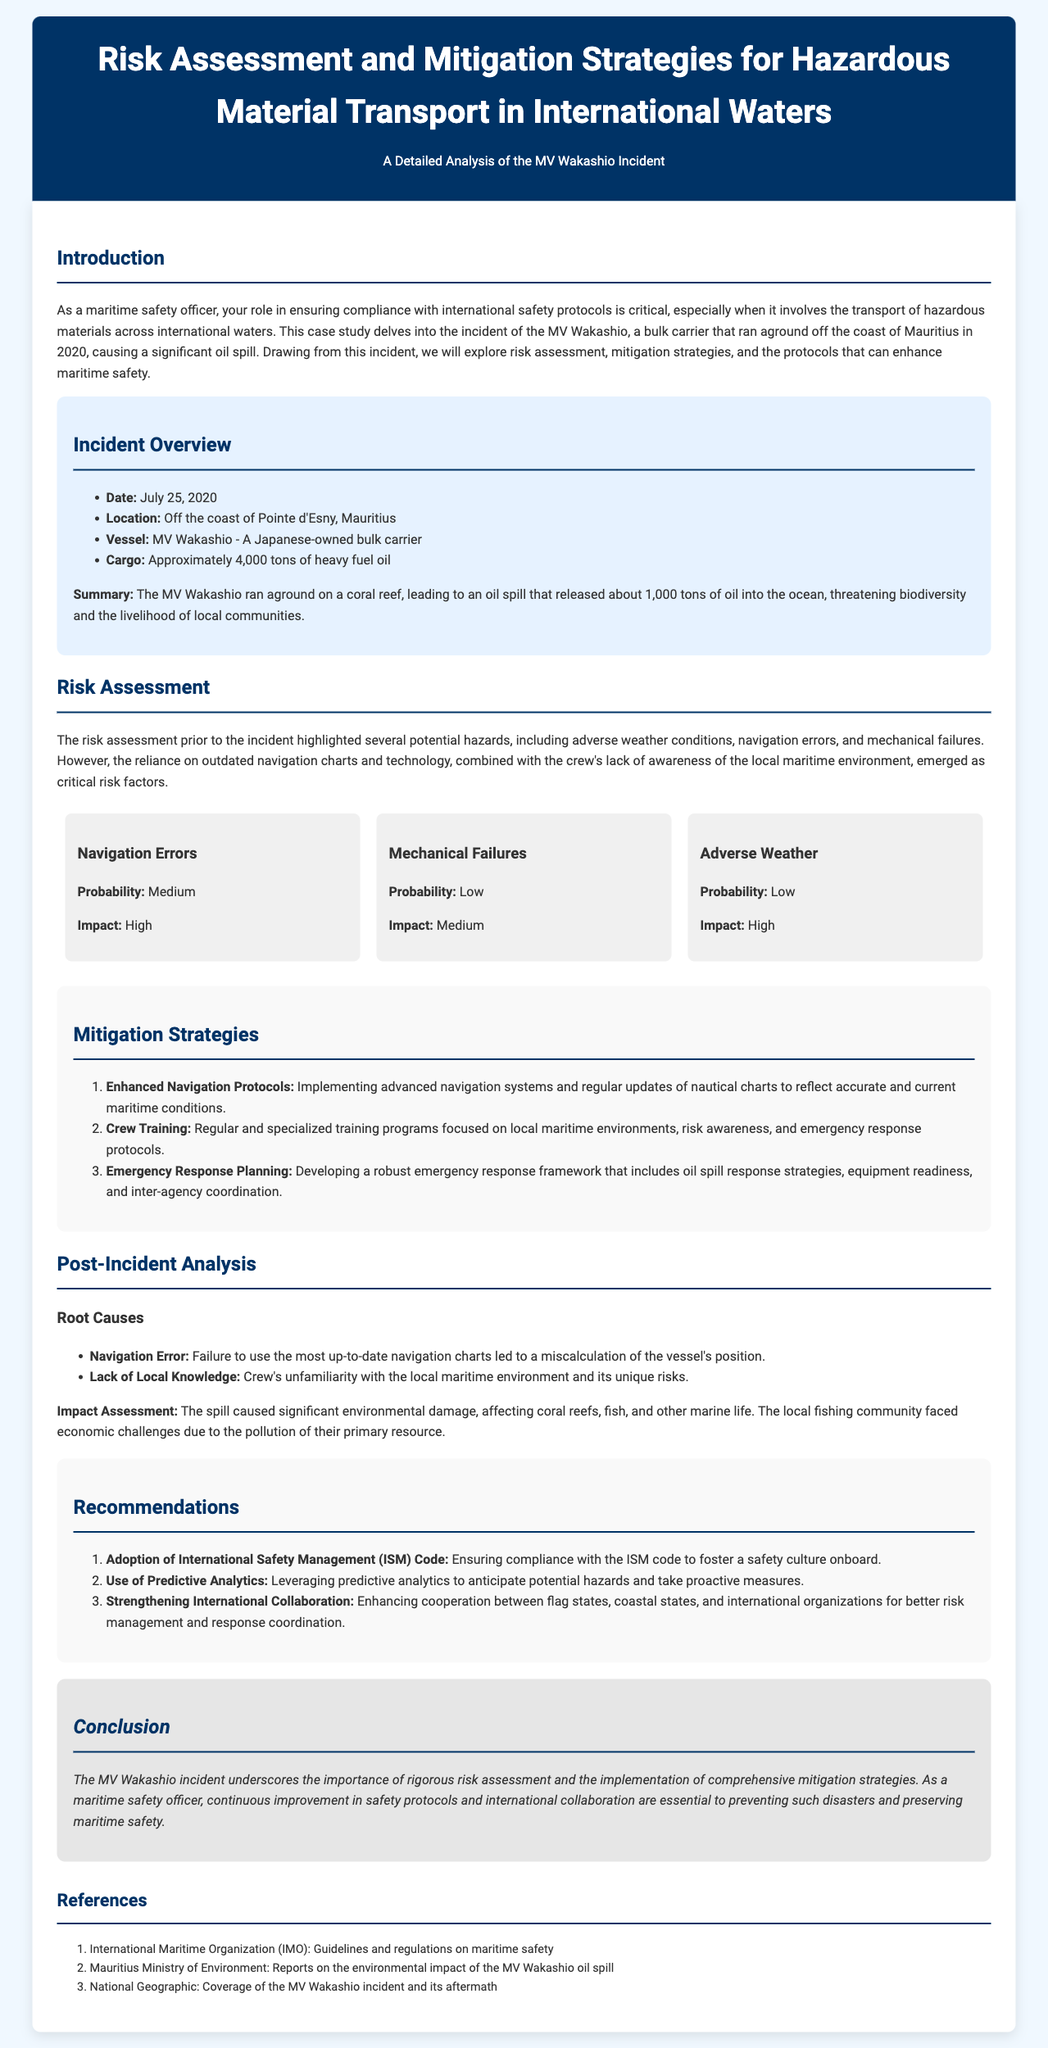What was the date of the MV Wakashio incident? The date of the incident is clearly stated in the document as July 25, 2020.
Answer: July 25, 2020 What type of cargo did the MV Wakashio carry? The document specifies the type of cargo as heavy fuel oil, which is critical in understanding the incident's implications.
Answer: Heavy fuel oil What was the approximate amount of oil released into the ocean? The document mentions that around 1,000 tons of oil were released during the spill.
Answer: 1,000 tons What were the two root causes identified post-incident? The document lists navigation error and lack of local knowledge as the primary root causes of the incident.
Answer: Navigation error, Lack of local knowledge What mitigation strategy focuses on the crew's training? The strategy that emphasizes crew training is identified in the document, highlighting the importance of preparedness.
Answer: Crew Training What impact did the oil spill have on the local community? The document states that the local fishing community faced economic challenges due to the pollution.
Answer: Economic challenges According to the document, how many mitigation strategies are listed? The document presents three specific mitigation strategies in the section dedicated to mitigation strategies.
Answer: Three What does ISM stand for in the context of the recommendations? The document refers to ISM as the International Safety Management code, which is crucial for maritime safety culture.
Answer: International Safety Management What environmental feature was primarily affected by the oil spill according to the impact assessment? The document highlights coral reefs as a significant environmental feature negatively impacted by the spill.
Answer: Coral reefs 